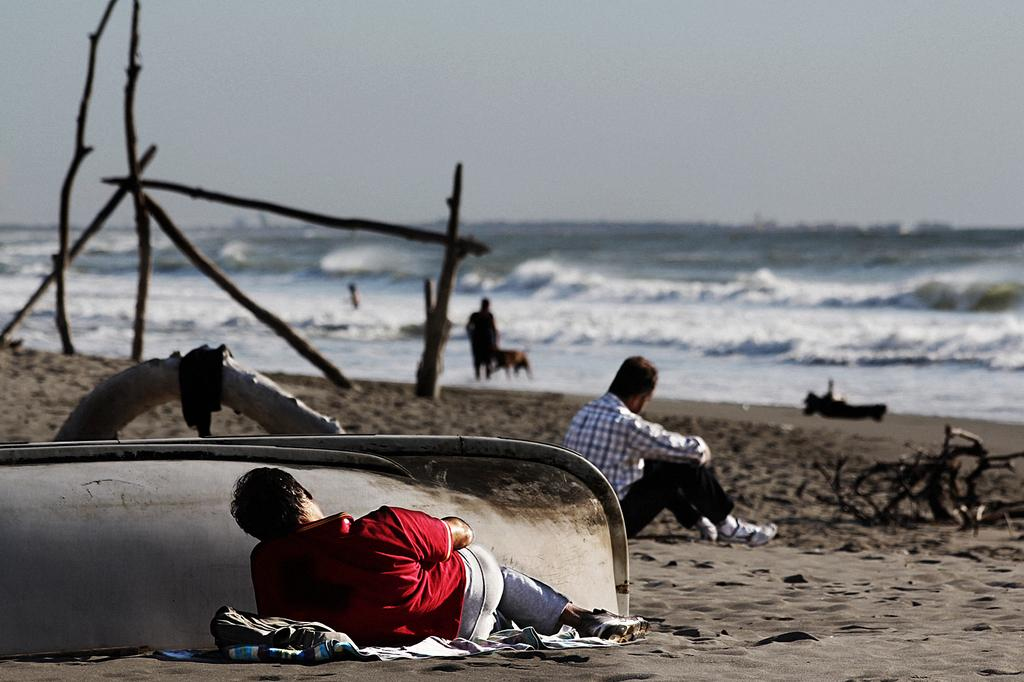Where was the image taken? The image was taken near a beach. What can be seen in the foreground of the image? There are people, wooden logs, sand, a boat, and other objects in the foreground of the image. What is the primary feature of the beach? The primary feature of the beach is the sand. What is visible in the background of the image? There is a water body in the background of the image. What is visible at the top of the image? The sky is visible at the top of the image. Where is the stove located in the image? There is no stove present in the image. How many pails of water are visible in the image? There are no pails of water visible in the image. 